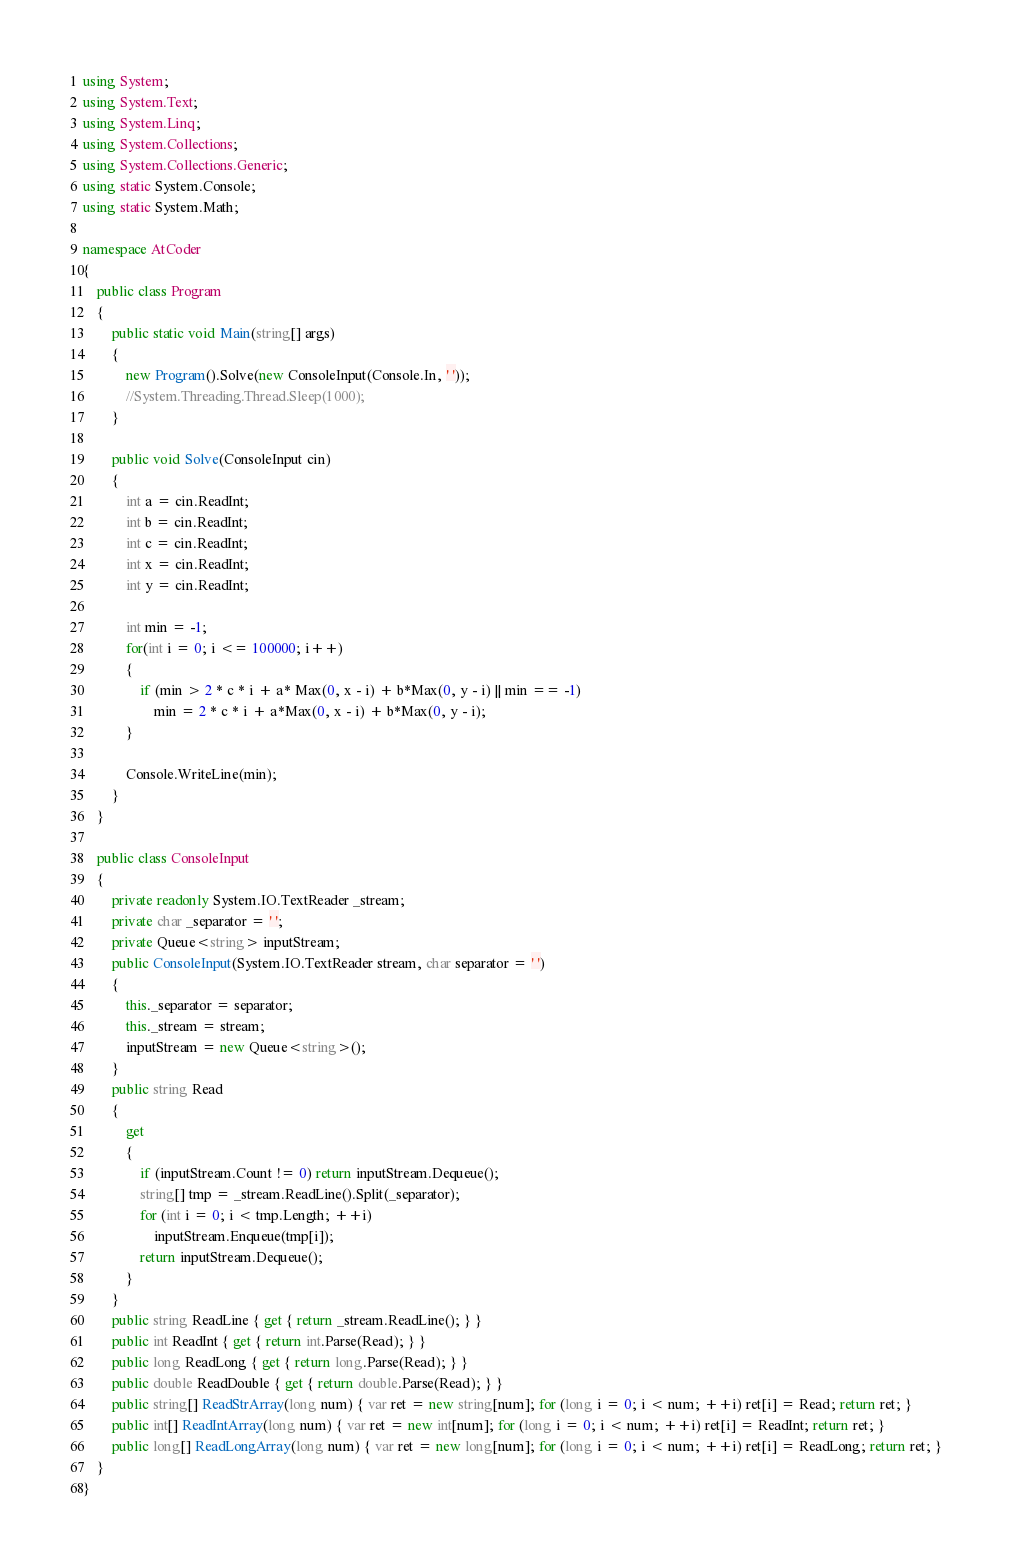Convert code to text. <code><loc_0><loc_0><loc_500><loc_500><_C#_>using System;
using System.Text;
using System.Linq;
using System.Collections;
using System.Collections.Generic;
using static System.Console;
using static System.Math;

namespace AtCoder
{
    public class Program
    {
        public static void Main(string[] args)
        {
            new Program().Solve(new ConsoleInput(Console.In, ' '));
            //System.Threading.Thread.Sleep(1000);
        }

        public void Solve(ConsoleInput cin)
        {
            int a = cin.ReadInt;
            int b = cin.ReadInt;
            int c = cin.ReadInt;
            int x = cin.ReadInt;
            int y = cin.ReadInt;

            int min = -1;
            for(int i = 0; i <= 100000; i++)
            {
                if (min > 2 * c * i + a* Max(0, x - i) + b*Max(0, y - i) || min == -1)
                    min = 2 * c * i + a*Max(0, x - i) + b*Max(0, y - i);
            }

            Console.WriteLine(min);
        }
    }

    public class ConsoleInput
    {
        private readonly System.IO.TextReader _stream;
        private char _separator = ' ';
        private Queue<string> inputStream;
        public ConsoleInput(System.IO.TextReader stream, char separator = ' ')
        {
            this._separator = separator;
            this._stream = stream;
            inputStream = new Queue<string>();
        }
        public string Read
        {
            get
            {
                if (inputStream.Count != 0) return inputStream.Dequeue();
                string[] tmp = _stream.ReadLine().Split(_separator);
                for (int i = 0; i < tmp.Length; ++i)
                    inputStream.Enqueue(tmp[i]);
                return inputStream.Dequeue();
            }
        }
        public string ReadLine { get { return _stream.ReadLine(); } }
        public int ReadInt { get { return int.Parse(Read); } }
        public long ReadLong { get { return long.Parse(Read); } }
        public double ReadDouble { get { return double.Parse(Read); } }
        public string[] ReadStrArray(long num) { var ret = new string[num]; for (long i = 0; i < num; ++i) ret[i] = Read; return ret; }
        public int[] ReadIntArray(long num) { var ret = new int[num]; for (long i = 0; i < num; ++i) ret[i] = ReadInt; return ret; }
        public long[] ReadLongArray(long num) { var ret = new long[num]; for (long i = 0; i < num; ++i) ret[i] = ReadLong; return ret; }
    }
}</code> 